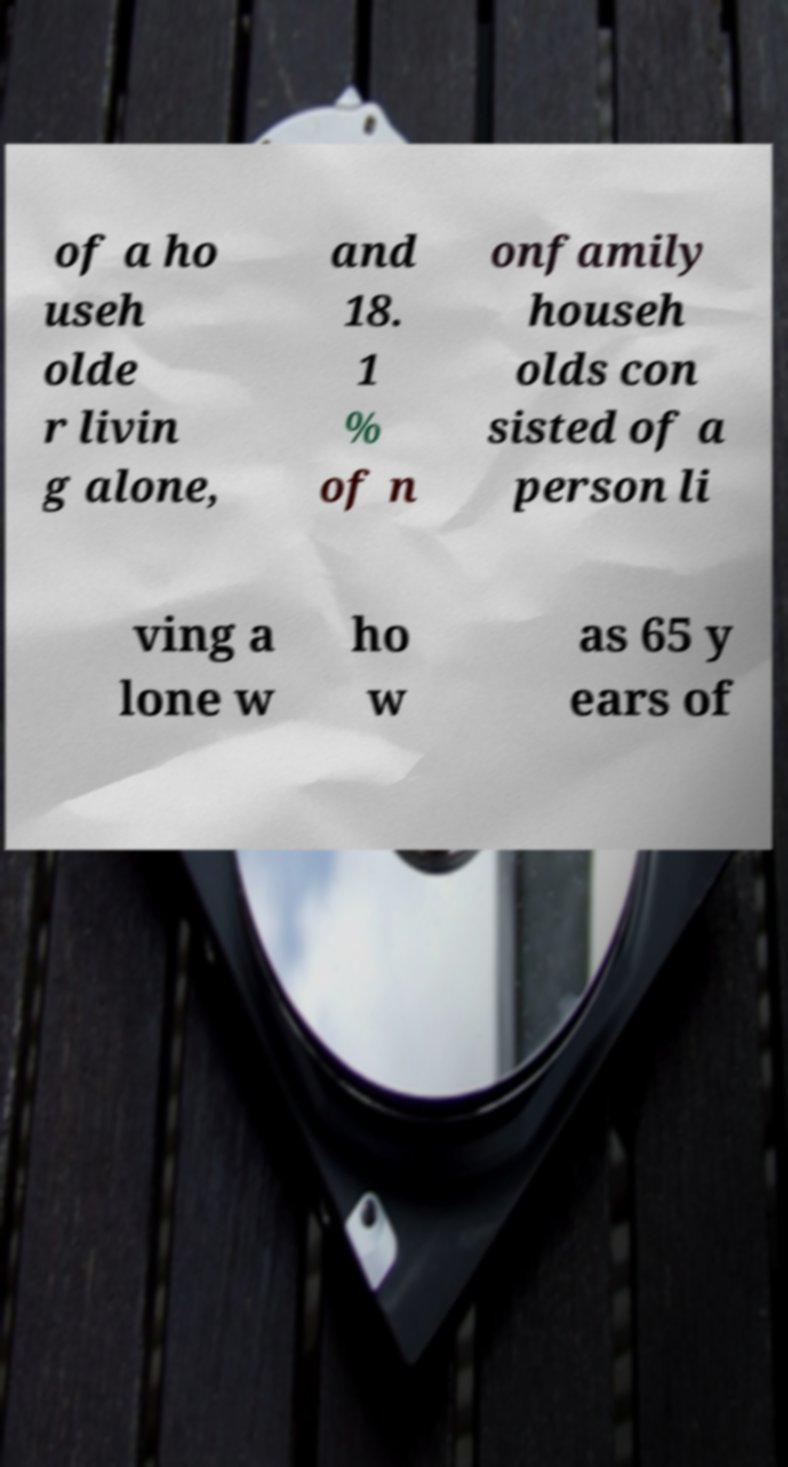Can you accurately transcribe the text from the provided image for me? of a ho useh olde r livin g alone, and 18. 1 % of n onfamily househ olds con sisted of a person li ving a lone w ho w as 65 y ears of 